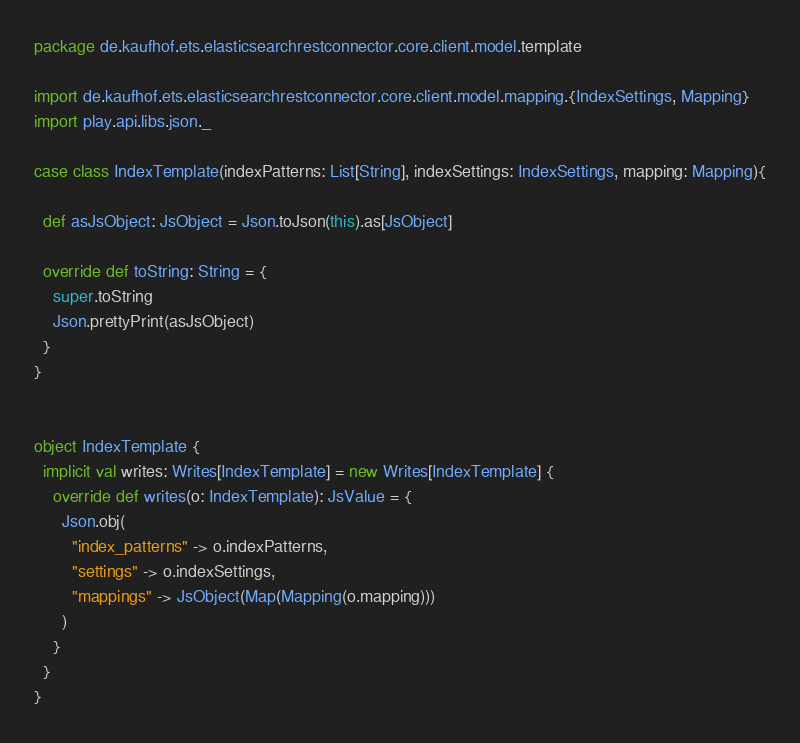Convert code to text. <code><loc_0><loc_0><loc_500><loc_500><_Scala_>package de.kaufhof.ets.elasticsearchrestconnector.core.client.model.template

import de.kaufhof.ets.elasticsearchrestconnector.core.client.model.mapping.{IndexSettings, Mapping}
import play.api.libs.json._

case class IndexTemplate(indexPatterns: List[String], indexSettings: IndexSettings, mapping: Mapping){

  def asJsObject: JsObject = Json.toJson(this).as[JsObject]

  override def toString: String = {
    super.toString
    Json.prettyPrint(asJsObject)
  }
}


object IndexTemplate {
  implicit val writes: Writes[IndexTemplate] = new Writes[IndexTemplate] {
    override def writes(o: IndexTemplate): JsValue = {
      Json.obj(
        "index_patterns" -> o.indexPatterns,
        "settings" -> o.indexSettings,
        "mappings" -> JsObject(Map(Mapping(o.mapping)))
      )
    }
  }
}</code> 